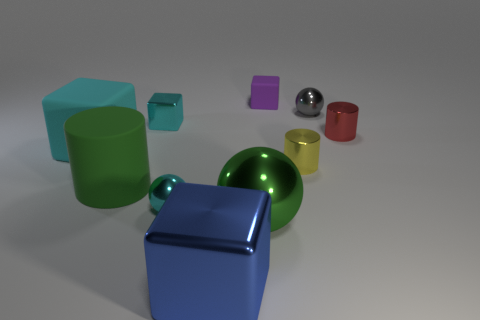What shapes are present in the image? The image includes a variety of geometric shapes: cubes, cylinders, and spheres. Can you tell me more about their arrangement? The objects are arranged sporadically across a flat surface with no apparent pattern. Some objects are closer to the forefront, like the large blue cube, while others are farther away, creating depth in the image. 